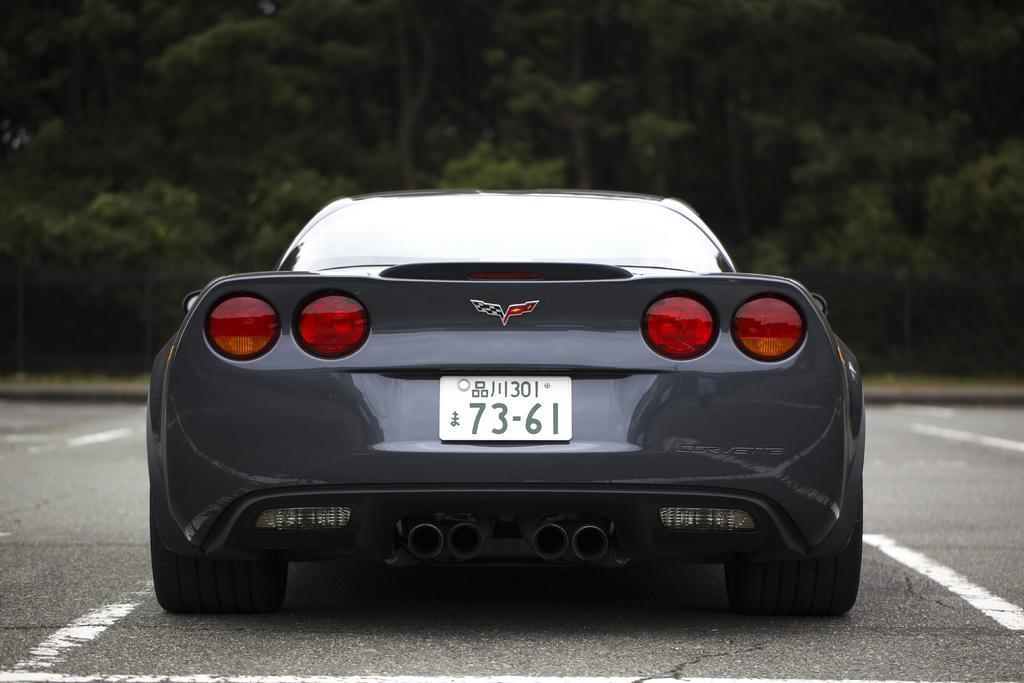<image>
Relay a brief, clear account of the picture shown. A grey Corvette that is displaying a foreign license plate with the numbers 73-61 on it. 